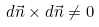Convert formula to latex. <formula><loc_0><loc_0><loc_500><loc_500>d \vec { n } \times d \vec { n } \neq 0</formula> 